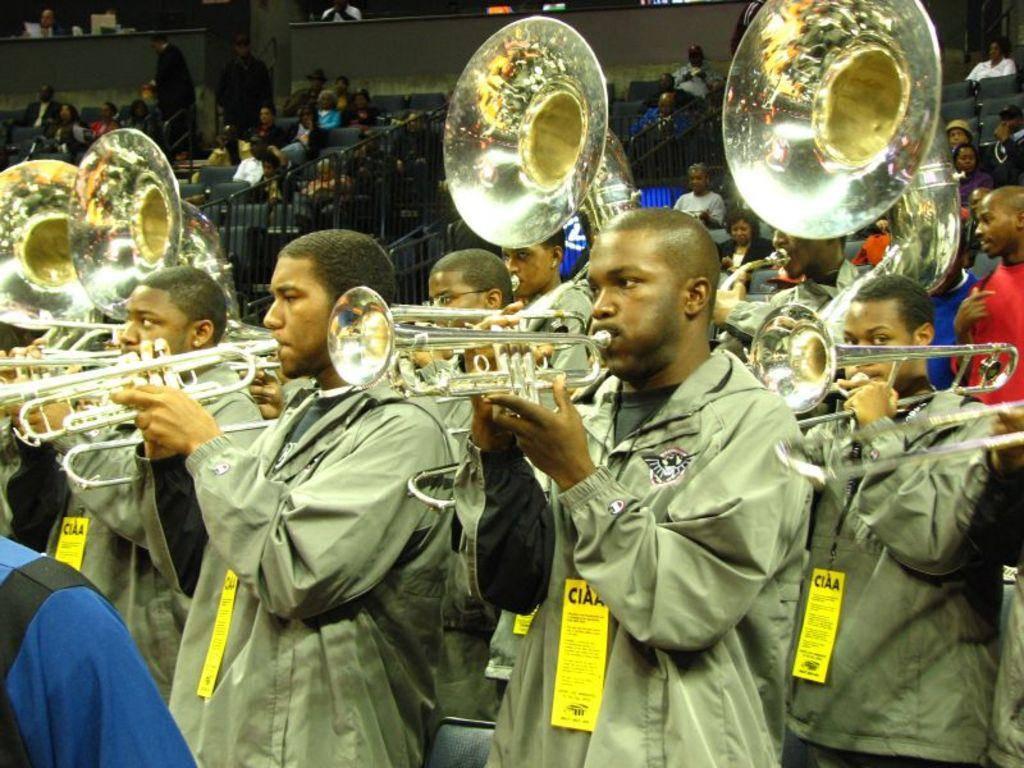What are the people in the image doing? The people in the image are playing musical instruments. Can you describe the setting of the image? There is railing visible in the background of the image. What can be observed about the people in the background? There are people with different color dresses in the background of the image. What type of scarecrow can be seen resting in the image? There is no scarecrow present in the image, and therefore no such activity can be observed. How does the dust affect the musical performance in the image? There is no mention of dust in the image, so its impact on the musical performance cannot be determined. 